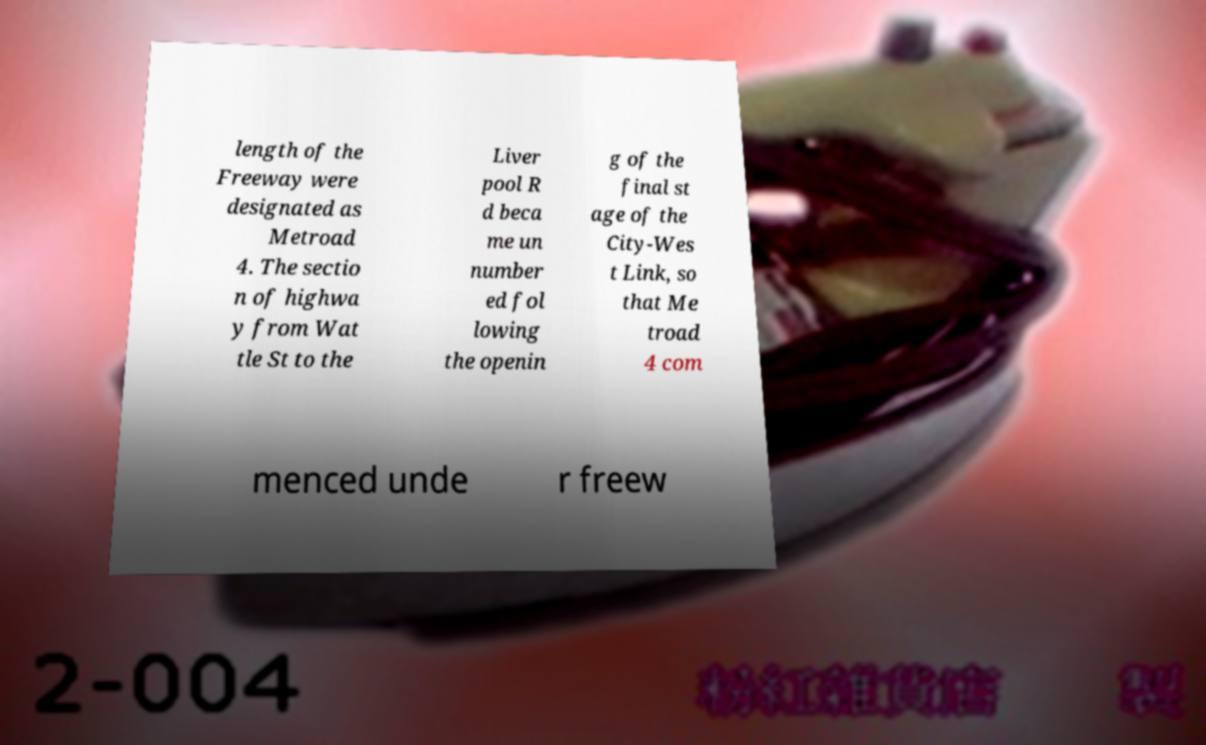I need the written content from this picture converted into text. Can you do that? length of the Freeway were designated as Metroad 4. The sectio n of highwa y from Wat tle St to the Liver pool R d beca me un number ed fol lowing the openin g of the final st age of the City-Wes t Link, so that Me troad 4 com menced unde r freew 